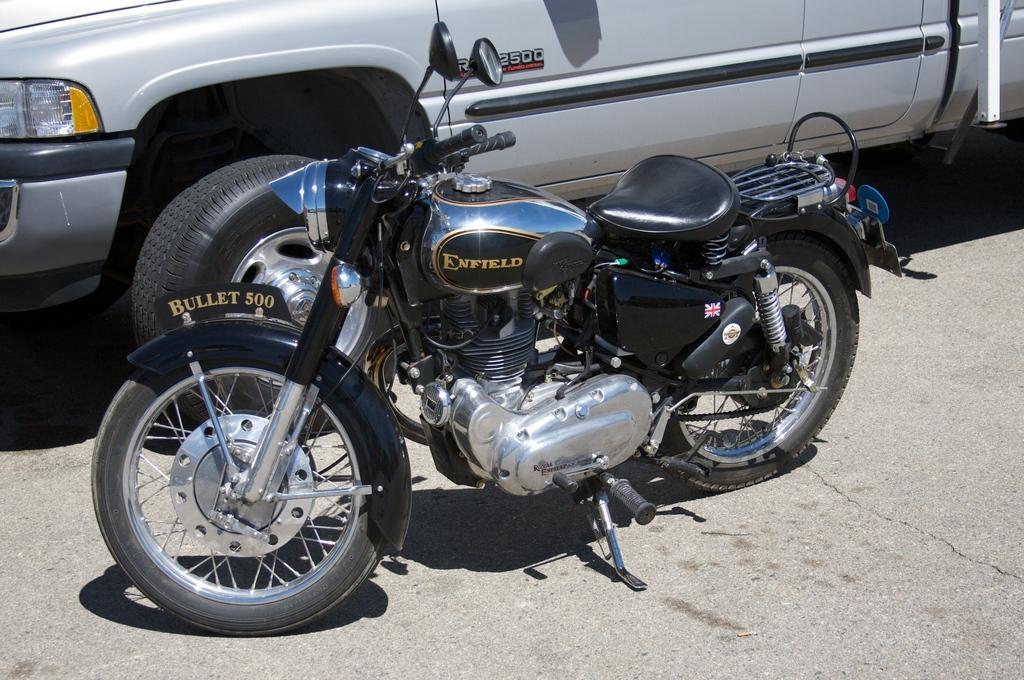Can you describe this image briefly? In this picture we can see the silver and black color enfield bike parked on the road. In the background there is a silver car. 